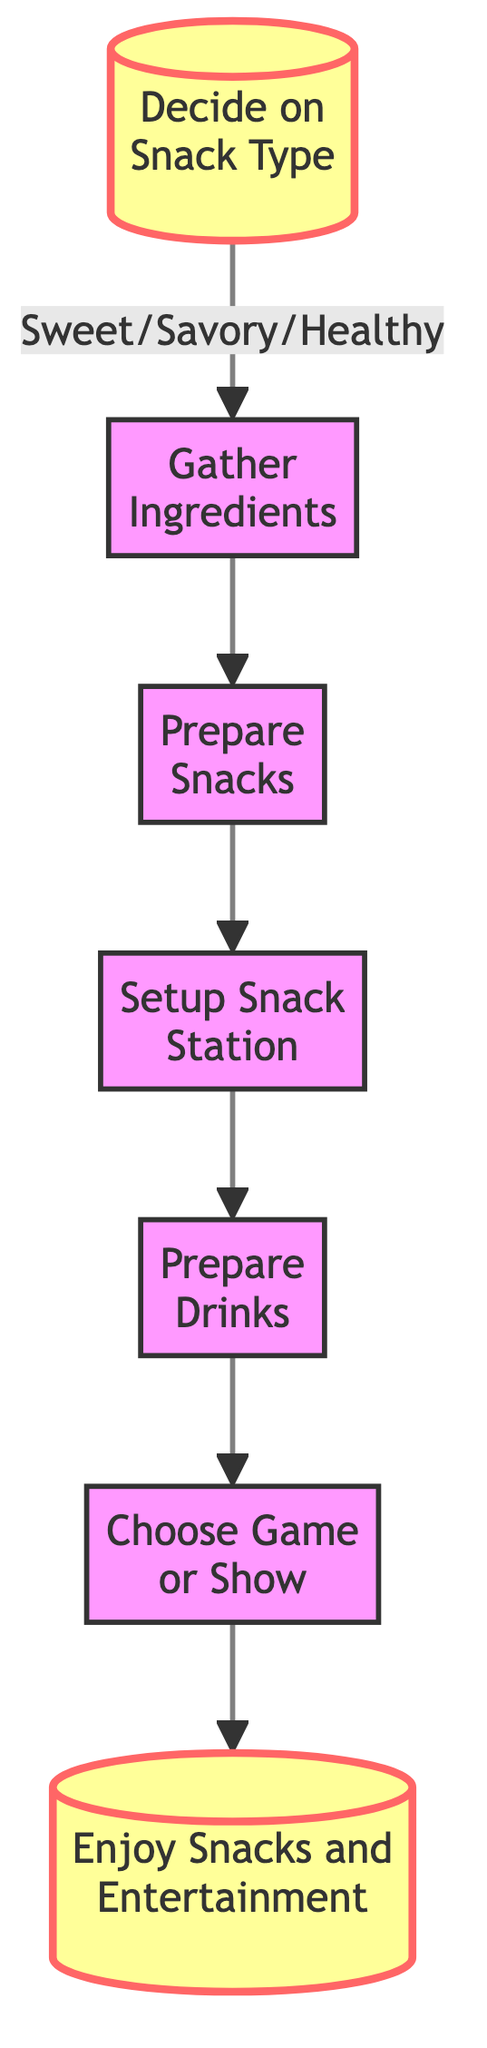What is the first step in the snack preparation workflow? The first step is to "Decide on Snack Type", which is indicated as the starting node in the flowchart.
Answer: Decide on Snack Type How many nodes are in the diagram? There are 7 nodes present in the flowchart, each representing a step in the snack preparation process.
Answer: 7 What follows after "Gather Ingredients"? The next step after "Gather Ingredients" is "Prepare Snacks", which is directly connected in the flow of the diagram.
Answer: Prepare Snacks What is the final step in this workflow? The final step is "Enjoy Snacks and Entertainment", which is the last node that leads out of the workflow.
Answer: Enjoy Snacks and Entertainment Is "Prepare Drinks" before or after "Setup Snack Station"? "Prepare Drinks" comes after "Setup Snack Station" in the flow of the diagram, as indicated by the arrows connecting the nodes.
Answer: After What snack types can be chosen in the first step? The options are sweet, savory, or healthy snacks, as stated in the description of the "Decide on Snack Type" node.
Answer: Sweet/Savory/Healthy Which step directly connects to "Choose Game or Show"? "Prepare Drinks" directly connects to "Choose Game or Show", indicating the sequence in the preparation workflow.
Answer: Prepare Drinks What is the relationship between "Prepare Snacks" and "Setup Snack Station"? "Prepare Snacks" leads directly to "Setup Snack Station", showing that after preparation, the snacks need to be arranged for serving.
Answer: Leads to Which node does the "Prepare Drinks" step flow into? The "Prepare Drinks" step flows into "Choose Game or Show", indicating the next action after drinks are ready.
Answer: Choose Game or Show 